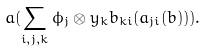<formula> <loc_0><loc_0><loc_500><loc_500>a ( \sum _ { i , j , k } \phi _ { j } \otimes y _ { k } b _ { k i } ( a _ { j i } ( b ) ) ) .</formula> 